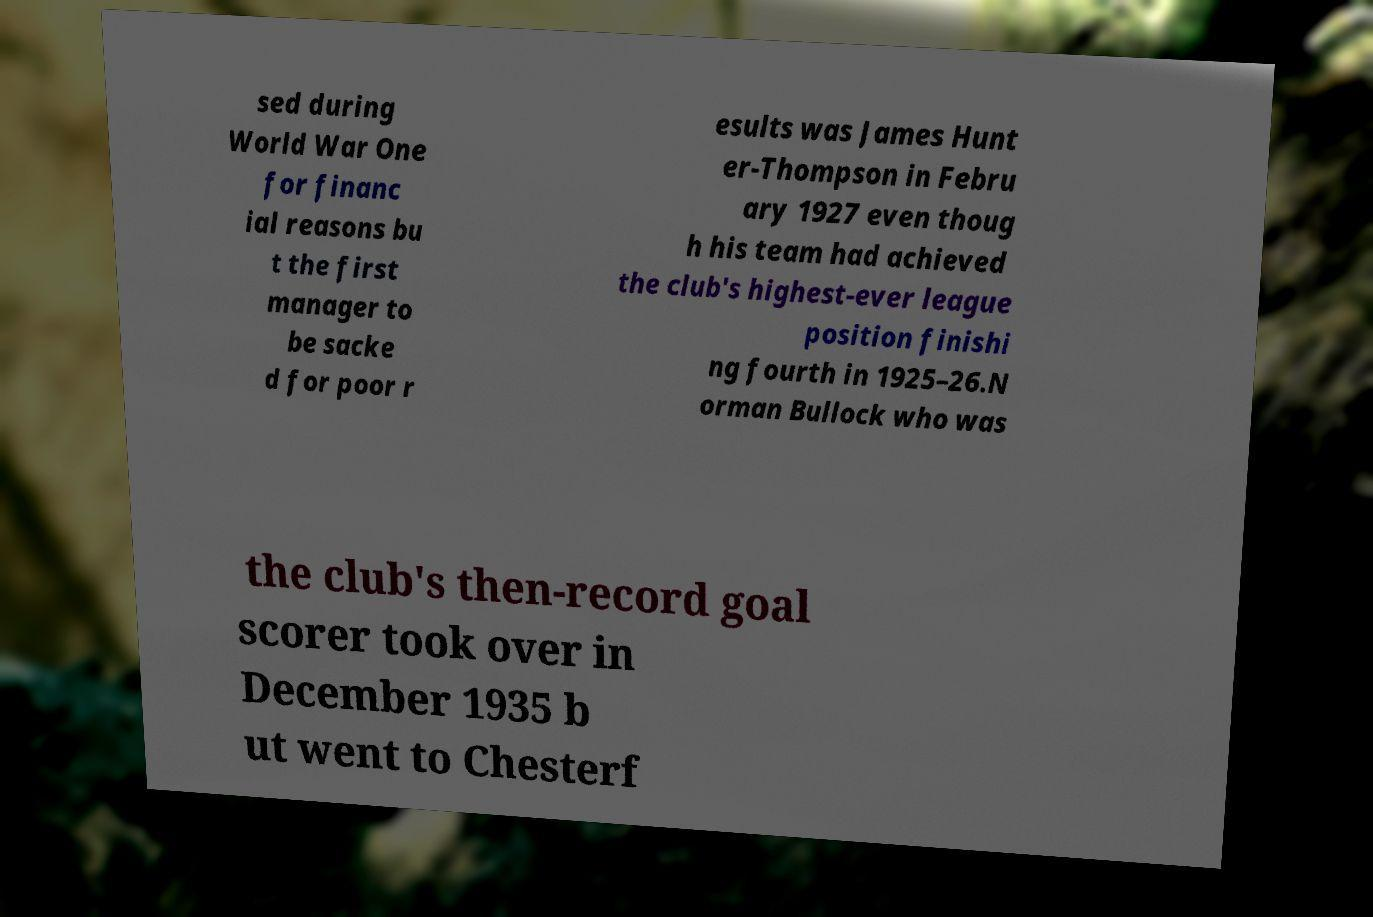Please read and relay the text visible in this image. What does it say? sed during World War One for financ ial reasons bu t the first manager to be sacke d for poor r esults was James Hunt er-Thompson in Febru ary 1927 even thoug h his team had achieved the club's highest-ever league position finishi ng fourth in 1925–26.N orman Bullock who was the club's then-record goal scorer took over in December 1935 b ut went to Chesterf 